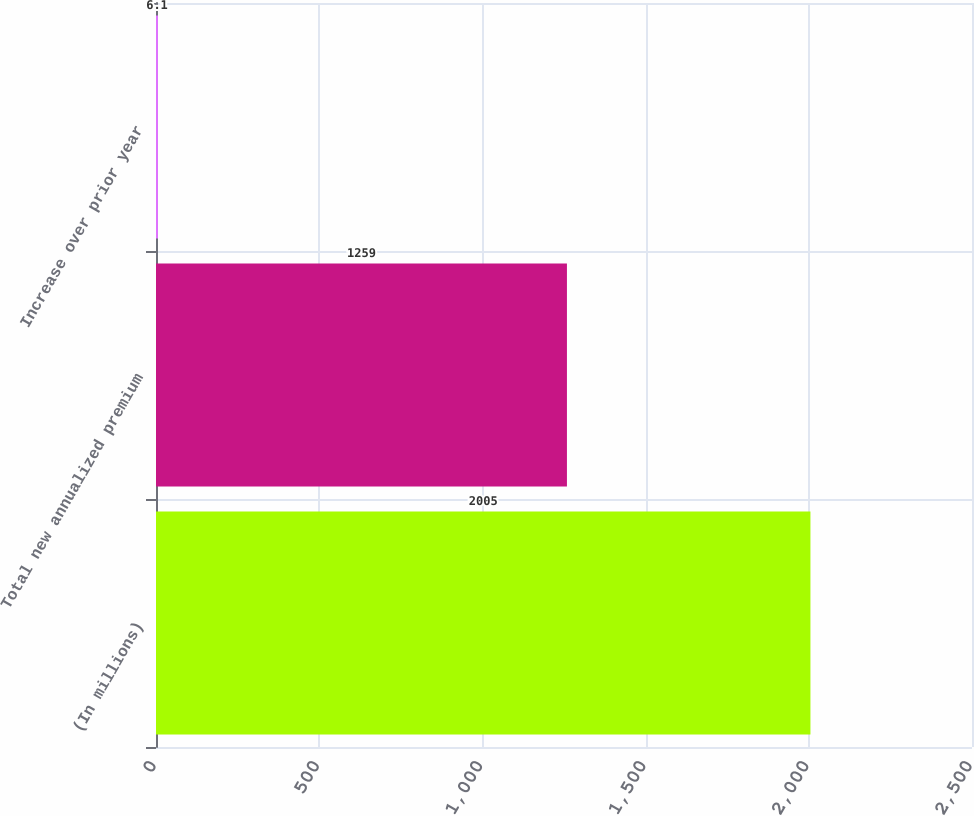Convert chart to OTSL. <chart><loc_0><loc_0><loc_500><loc_500><bar_chart><fcel>(In millions)<fcel>Total new annualized premium<fcel>Increase over prior year<nl><fcel>2005<fcel>1259<fcel>6.1<nl></chart> 